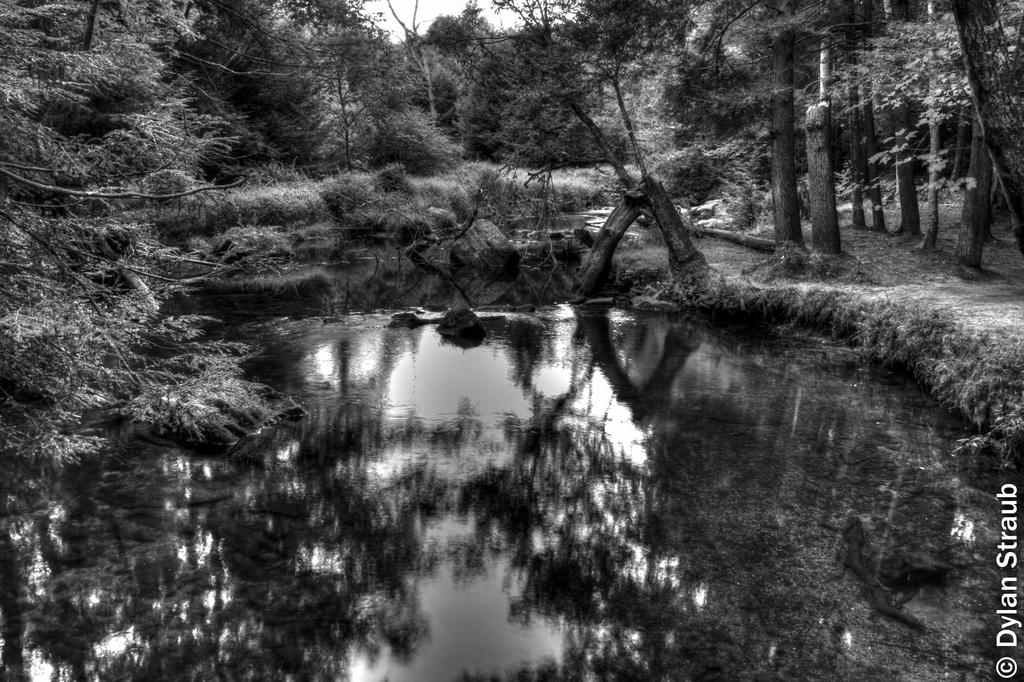What is located at the bottom of the image? There is a pond at the bottom of the image. What can be seen at the top of the image? There are trees at the top of the image. Is there any text or marking in the image? Yes, there is a watermark in the right-hand side bottom of the image. How many boats are visible in the image? There are no boats present in the image. What is the name of the daughter in the image? There is no person, let alone a daughter, depicted in the image. 